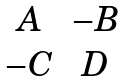<formula> <loc_0><loc_0><loc_500><loc_500>\begin{matrix} A & - B \\ - C & D \end{matrix}</formula> 